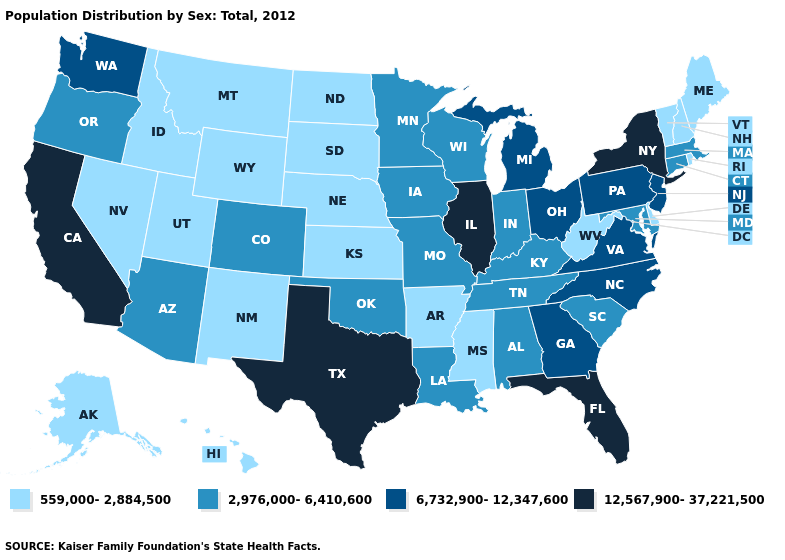What is the lowest value in states that border Mississippi?
Answer briefly. 559,000-2,884,500. Does Arkansas have a lower value than South Carolina?
Concise answer only. Yes. What is the value of South Dakota?
Concise answer only. 559,000-2,884,500. What is the value of Nebraska?
Give a very brief answer. 559,000-2,884,500. What is the value of West Virginia?
Quick response, please. 559,000-2,884,500. What is the highest value in the Northeast ?
Short answer required. 12,567,900-37,221,500. Name the states that have a value in the range 6,732,900-12,347,600?
Concise answer only. Georgia, Michigan, New Jersey, North Carolina, Ohio, Pennsylvania, Virginia, Washington. What is the value of Florida?
Write a very short answer. 12,567,900-37,221,500. Which states have the lowest value in the USA?
Short answer required. Alaska, Arkansas, Delaware, Hawaii, Idaho, Kansas, Maine, Mississippi, Montana, Nebraska, Nevada, New Hampshire, New Mexico, North Dakota, Rhode Island, South Dakota, Utah, Vermont, West Virginia, Wyoming. What is the value of Hawaii?
Keep it brief. 559,000-2,884,500. What is the value of Indiana?
Give a very brief answer. 2,976,000-6,410,600. What is the highest value in the South ?
Write a very short answer. 12,567,900-37,221,500. Does Delaware have the same value as Nebraska?
Write a very short answer. Yes. What is the highest value in states that border Texas?
Concise answer only. 2,976,000-6,410,600. Among the states that border Connecticut , does New York have the lowest value?
Be succinct. No. 